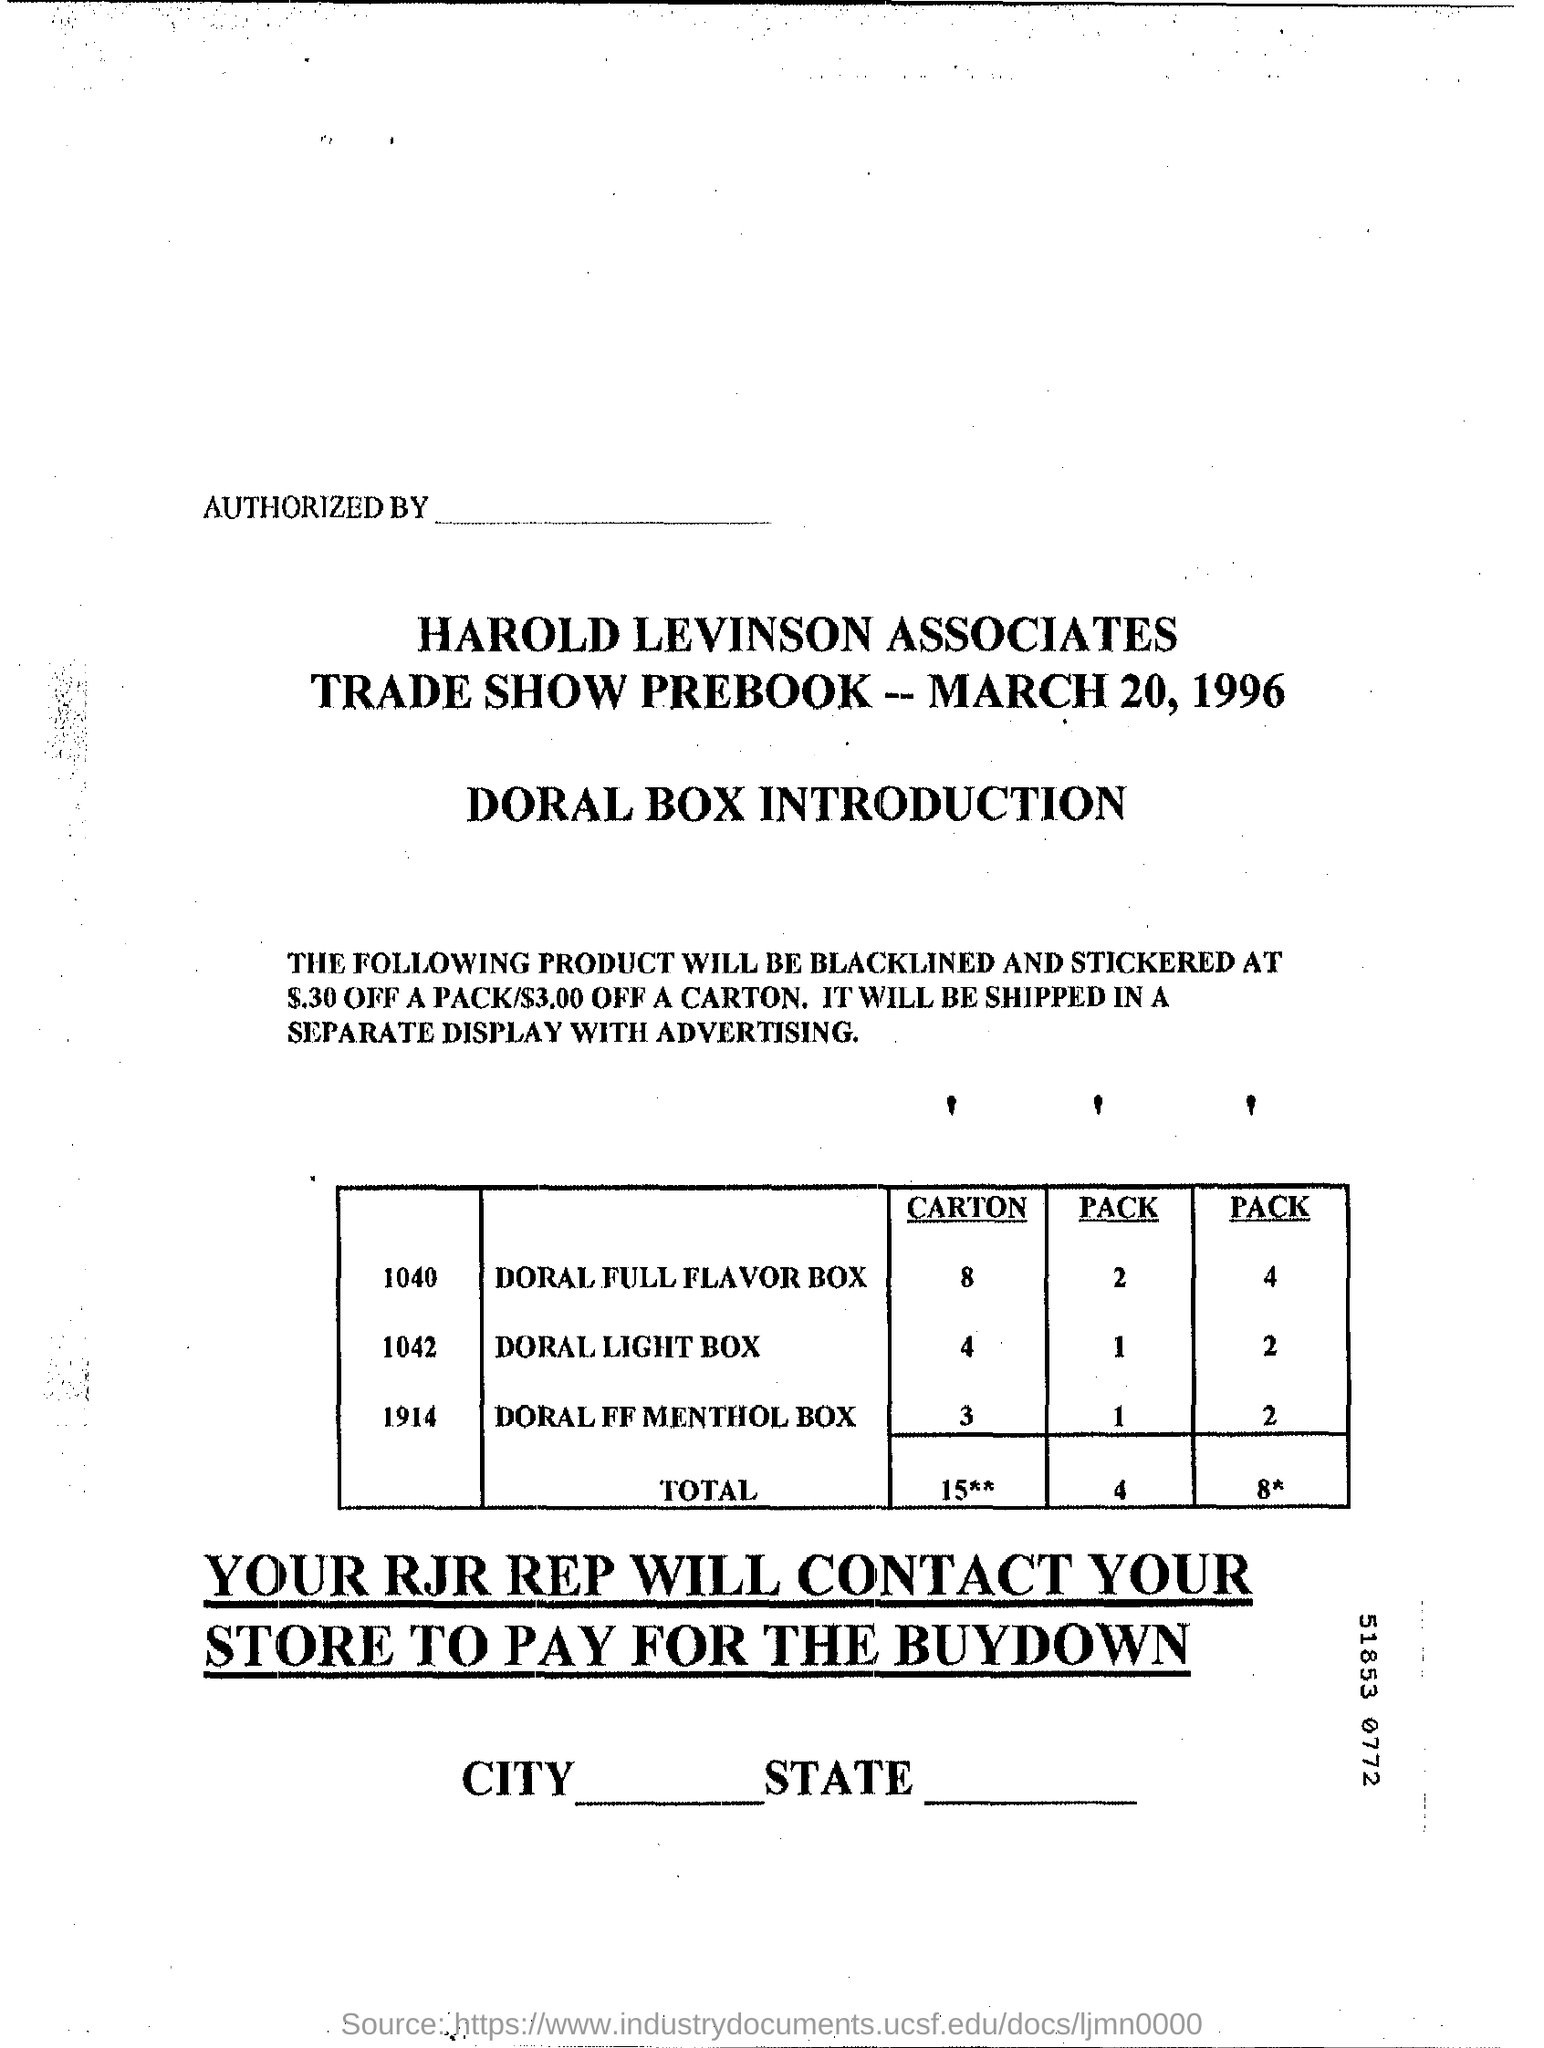List a handful of essential elements in this visual. We require 2 units of the Doral Light Box carton. The date on the document is March 20, 1996. 